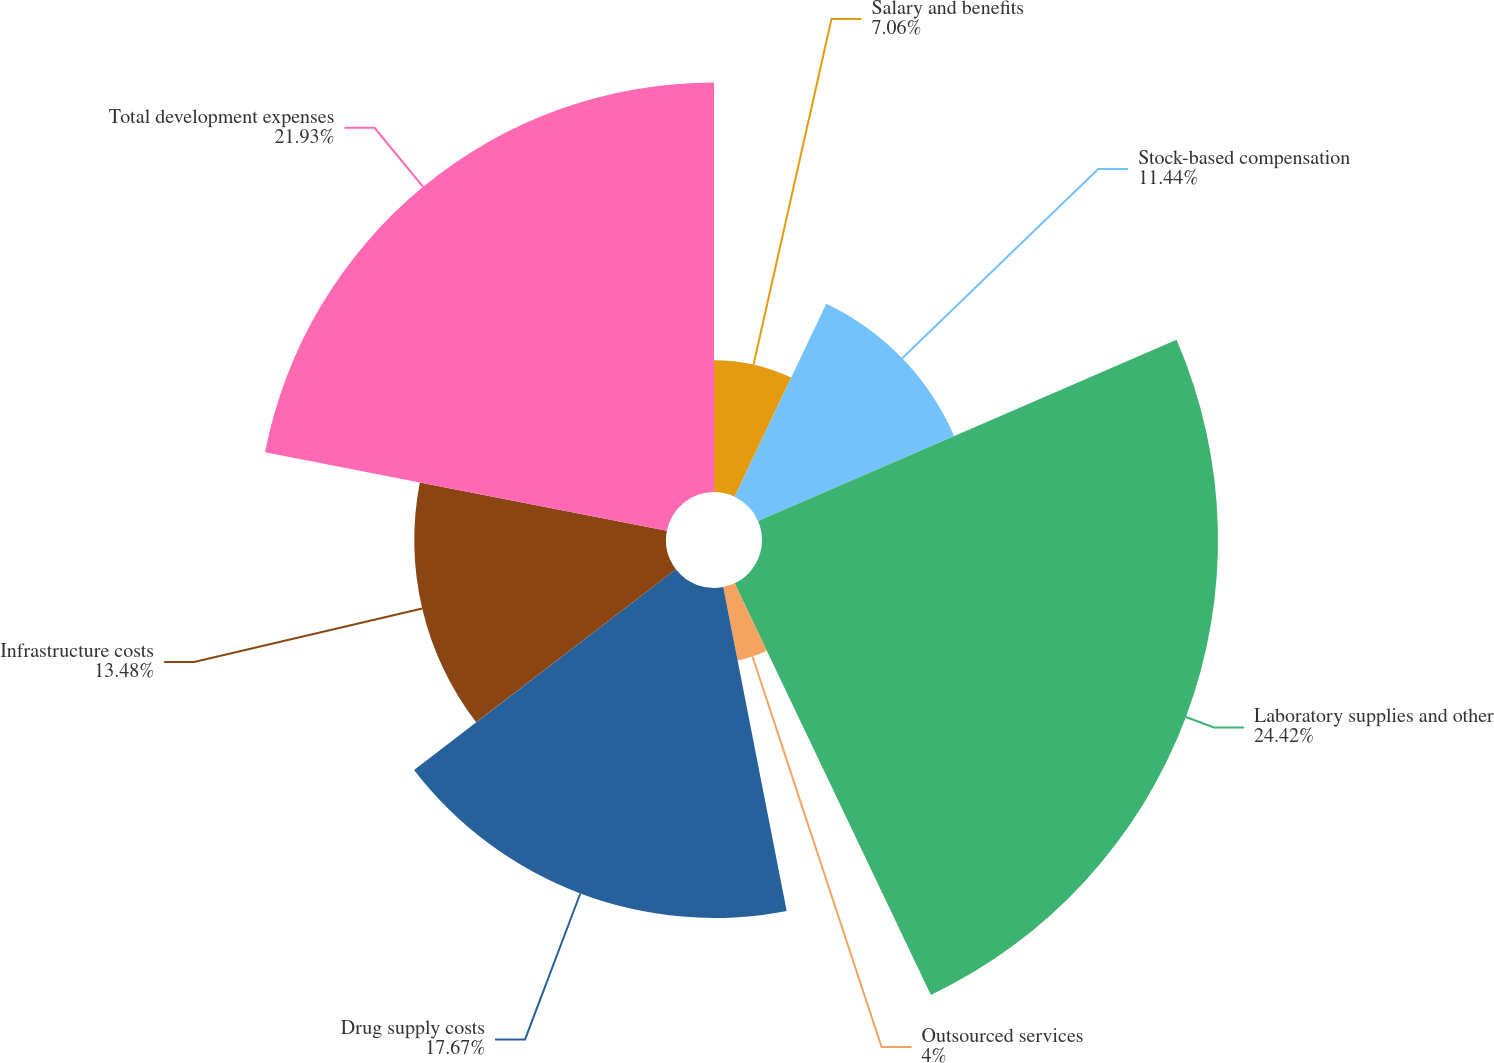<chart> <loc_0><loc_0><loc_500><loc_500><pie_chart><fcel>Salary and benefits<fcel>Stock-based compensation<fcel>Laboratory supplies and other<fcel>Outsourced services<fcel>Drug supply costs<fcel>Infrastructure costs<fcel>Total development expenses<nl><fcel>7.06%<fcel>11.44%<fcel>24.42%<fcel>4.0%<fcel>17.67%<fcel>13.48%<fcel>21.93%<nl></chart> 